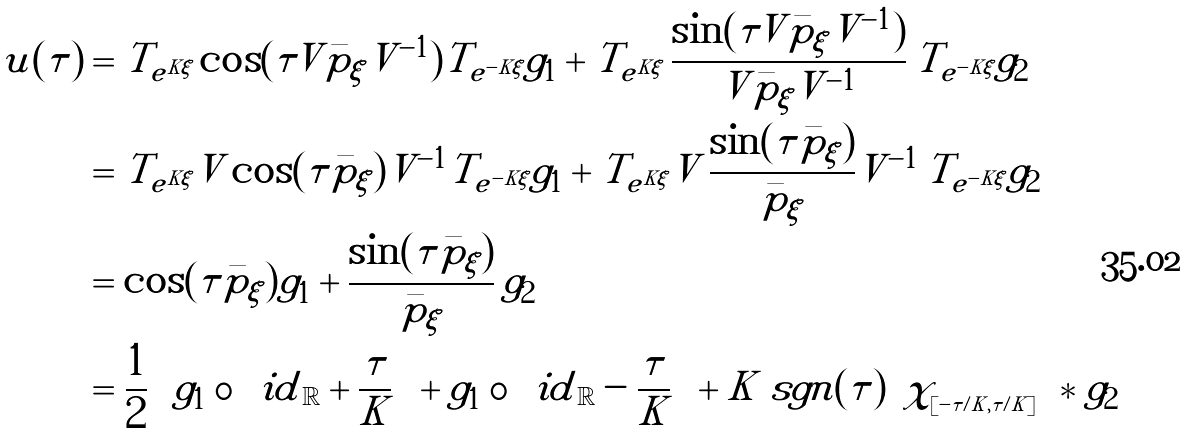<formula> <loc_0><loc_0><loc_500><loc_500>u ( \tau ) & = T _ { e ^ { K \xi } } \cos ( \tau V \bar { p } _ { \xi } V ^ { - 1 } ) T _ { e ^ { - K \xi } } g _ { 1 } + T _ { e ^ { K \xi } } \, \frac { \sin ( \tau V \bar { p } _ { \xi } V ^ { - 1 } ) } { V \bar { p } _ { \xi } V ^ { - 1 } } \, T _ { e ^ { - K \xi } } g _ { 2 } \\ & = T _ { e ^ { K \xi } } V \cos ( \tau \bar { p } _ { \xi } ) V ^ { - 1 } T _ { e ^ { - K \xi } } g _ { 1 } + T _ { e ^ { K \xi } } V \, \frac { \sin ( \tau \bar { p } _ { \xi } ) } { \bar { p } _ { \xi } } V ^ { - 1 } \, T _ { e ^ { - K \xi } } g _ { 2 } \\ & = \cos ( \tau \bar { p } _ { \xi } ) g _ { 1 } + \frac { \sin ( \tau \bar { p } _ { \xi } ) } { \bar { p } _ { \xi } } \, g _ { 2 } \\ & = \frac { 1 } { 2 } \left [ g _ { 1 } \circ \left ( { i d } _ { \mathbb { R } } + \frac { \tau } { K } \right ) + g _ { 1 } \circ \left ( { i d } _ { \mathbb { R } } - \frac { \tau } { K } \right ) + K \ s g n ( \tau ) \left ( \chi _ { _ { [ - | \tau | / K , | \tau | / K ] } } * g _ { 2 } \right ) \right ]</formula> 